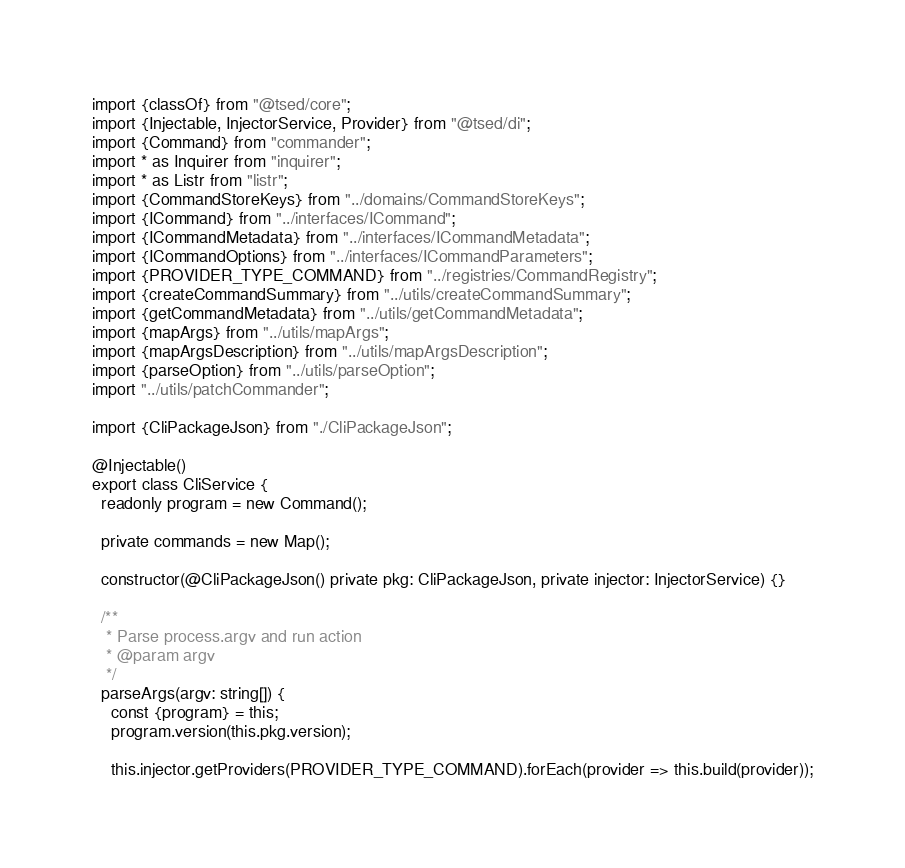<code> <loc_0><loc_0><loc_500><loc_500><_TypeScript_>import {classOf} from "@tsed/core";
import {Injectable, InjectorService, Provider} from "@tsed/di";
import {Command} from "commander";
import * as Inquirer from "inquirer";
import * as Listr from "listr";
import {CommandStoreKeys} from "../domains/CommandStoreKeys";
import {ICommand} from "../interfaces/ICommand";
import {ICommandMetadata} from "../interfaces/ICommandMetadata";
import {ICommandOptions} from "../interfaces/ICommandParameters";
import {PROVIDER_TYPE_COMMAND} from "../registries/CommandRegistry";
import {createCommandSummary} from "../utils/createCommandSummary";
import {getCommandMetadata} from "../utils/getCommandMetadata";
import {mapArgs} from "../utils/mapArgs";
import {mapArgsDescription} from "../utils/mapArgsDescription";
import {parseOption} from "../utils/parseOption";
import "../utils/patchCommander";

import {CliPackageJson} from "./CliPackageJson";

@Injectable()
export class CliService {
  readonly program = new Command();

  private commands = new Map();

  constructor(@CliPackageJson() private pkg: CliPackageJson, private injector: InjectorService) {}

  /**
   * Parse process.argv and run action
   * @param argv
   */
  parseArgs(argv: string[]) {
    const {program} = this;
    program.version(this.pkg.version);

    this.injector.getProviders(PROVIDER_TYPE_COMMAND).forEach(provider => this.build(provider));
</code> 